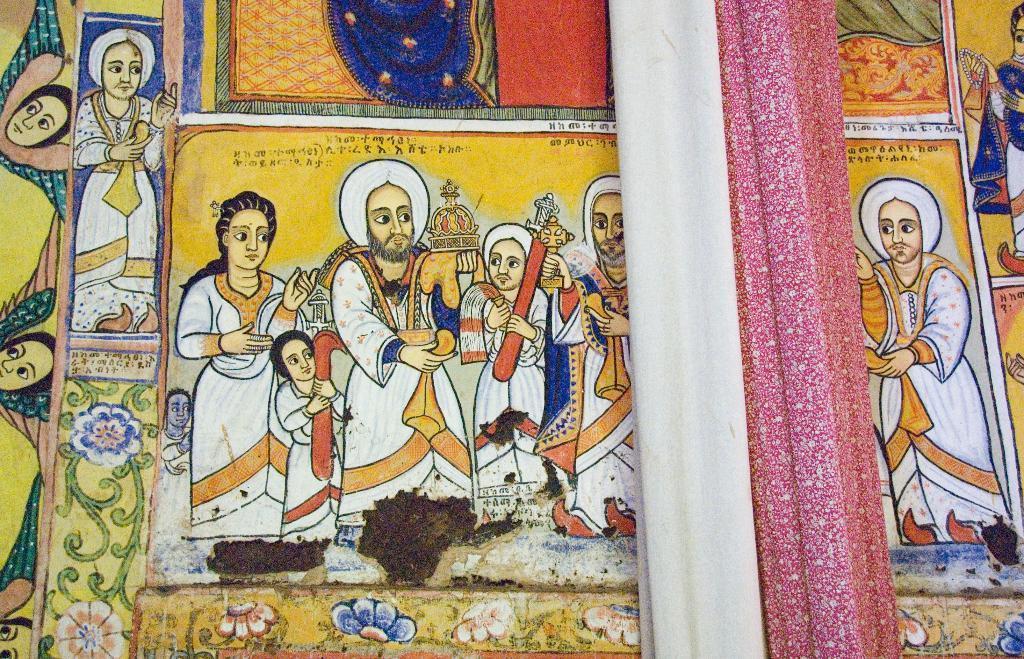Please provide a concise description of this image. Here in this picture we can see a painting present on the wall over there and in front of that we can see a curtain hanging over there. 